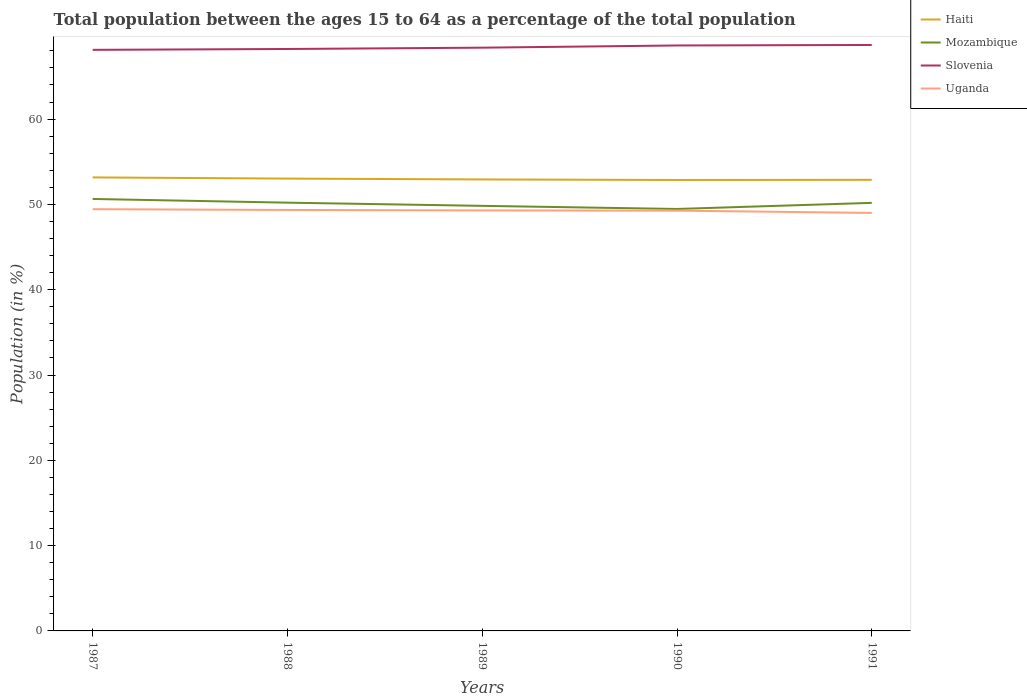Does the line corresponding to Slovenia intersect with the line corresponding to Uganda?
Provide a succinct answer. No. Is the number of lines equal to the number of legend labels?
Provide a succinct answer. Yes. Across all years, what is the maximum percentage of the population ages 15 to 64 in Mozambique?
Your answer should be very brief. 49.46. What is the total percentage of the population ages 15 to 64 in Haiti in the graph?
Your response must be concise. 0.1. What is the difference between the highest and the second highest percentage of the population ages 15 to 64 in Uganda?
Your answer should be very brief. 0.44. Is the percentage of the population ages 15 to 64 in Haiti strictly greater than the percentage of the population ages 15 to 64 in Uganda over the years?
Your answer should be very brief. No. How many lines are there?
Provide a succinct answer. 4. Are the values on the major ticks of Y-axis written in scientific E-notation?
Keep it short and to the point. No. Does the graph contain any zero values?
Keep it short and to the point. No. Does the graph contain grids?
Your answer should be compact. No. How are the legend labels stacked?
Provide a succinct answer. Vertical. What is the title of the graph?
Your response must be concise. Total population between the ages 15 to 64 as a percentage of the total population. What is the label or title of the X-axis?
Your response must be concise. Years. What is the Population (in %) in Haiti in 1987?
Make the answer very short. 53.16. What is the Population (in %) of Mozambique in 1987?
Provide a short and direct response. 50.64. What is the Population (in %) in Slovenia in 1987?
Offer a terse response. 68.12. What is the Population (in %) of Uganda in 1987?
Your answer should be compact. 49.44. What is the Population (in %) in Haiti in 1988?
Offer a terse response. 53.02. What is the Population (in %) of Mozambique in 1988?
Your response must be concise. 50.2. What is the Population (in %) in Slovenia in 1988?
Provide a succinct answer. 68.22. What is the Population (in %) of Uganda in 1988?
Provide a succinct answer. 49.35. What is the Population (in %) in Haiti in 1989?
Keep it short and to the point. 52.93. What is the Population (in %) in Mozambique in 1989?
Keep it short and to the point. 49.83. What is the Population (in %) of Slovenia in 1989?
Provide a succinct answer. 68.37. What is the Population (in %) of Uganda in 1989?
Offer a very short reply. 49.29. What is the Population (in %) of Haiti in 1990?
Your response must be concise. 52.86. What is the Population (in %) in Mozambique in 1990?
Provide a short and direct response. 49.46. What is the Population (in %) in Slovenia in 1990?
Offer a terse response. 68.63. What is the Population (in %) of Uganda in 1990?
Provide a short and direct response. 49.27. What is the Population (in %) in Haiti in 1991?
Keep it short and to the point. 52.88. What is the Population (in %) of Mozambique in 1991?
Offer a very short reply. 50.18. What is the Population (in %) in Slovenia in 1991?
Offer a very short reply. 68.69. What is the Population (in %) of Uganda in 1991?
Keep it short and to the point. 49. Across all years, what is the maximum Population (in %) in Haiti?
Your answer should be very brief. 53.16. Across all years, what is the maximum Population (in %) of Mozambique?
Offer a very short reply. 50.64. Across all years, what is the maximum Population (in %) in Slovenia?
Your answer should be compact. 68.69. Across all years, what is the maximum Population (in %) of Uganda?
Offer a terse response. 49.44. Across all years, what is the minimum Population (in %) in Haiti?
Make the answer very short. 52.86. Across all years, what is the minimum Population (in %) in Mozambique?
Your answer should be compact. 49.46. Across all years, what is the minimum Population (in %) of Slovenia?
Keep it short and to the point. 68.12. Across all years, what is the minimum Population (in %) of Uganda?
Offer a terse response. 49. What is the total Population (in %) of Haiti in the graph?
Your response must be concise. 264.85. What is the total Population (in %) in Mozambique in the graph?
Ensure brevity in your answer.  250.31. What is the total Population (in %) in Slovenia in the graph?
Offer a terse response. 342.02. What is the total Population (in %) in Uganda in the graph?
Make the answer very short. 246.34. What is the difference between the Population (in %) of Haiti in 1987 and that in 1988?
Provide a succinct answer. 0.14. What is the difference between the Population (in %) in Mozambique in 1987 and that in 1988?
Give a very brief answer. 0.43. What is the difference between the Population (in %) of Slovenia in 1987 and that in 1988?
Make the answer very short. -0.1. What is the difference between the Population (in %) in Uganda in 1987 and that in 1988?
Give a very brief answer. 0.09. What is the difference between the Population (in %) in Haiti in 1987 and that in 1989?
Your response must be concise. 0.24. What is the difference between the Population (in %) in Mozambique in 1987 and that in 1989?
Your answer should be compact. 0.81. What is the difference between the Population (in %) of Slovenia in 1987 and that in 1989?
Your response must be concise. -0.26. What is the difference between the Population (in %) in Uganda in 1987 and that in 1989?
Give a very brief answer. 0.15. What is the difference between the Population (in %) in Haiti in 1987 and that in 1990?
Your answer should be compact. 0.3. What is the difference between the Population (in %) of Mozambique in 1987 and that in 1990?
Provide a short and direct response. 1.17. What is the difference between the Population (in %) in Slovenia in 1987 and that in 1990?
Ensure brevity in your answer.  -0.51. What is the difference between the Population (in %) in Uganda in 1987 and that in 1990?
Keep it short and to the point. 0.17. What is the difference between the Population (in %) in Haiti in 1987 and that in 1991?
Your response must be concise. 0.28. What is the difference between the Population (in %) in Mozambique in 1987 and that in 1991?
Your answer should be compact. 0.46. What is the difference between the Population (in %) of Slovenia in 1987 and that in 1991?
Your answer should be compact. -0.57. What is the difference between the Population (in %) of Uganda in 1987 and that in 1991?
Your response must be concise. 0.44. What is the difference between the Population (in %) in Haiti in 1988 and that in 1989?
Keep it short and to the point. 0.1. What is the difference between the Population (in %) in Mozambique in 1988 and that in 1989?
Offer a very short reply. 0.37. What is the difference between the Population (in %) of Slovenia in 1988 and that in 1989?
Offer a very short reply. -0.15. What is the difference between the Population (in %) in Uganda in 1988 and that in 1989?
Provide a short and direct response. 0.06. What is the difference between the Population (in %) of Haiti in 1988 and that in 1990?
Offer a terse response. 0.16. What is the difference between the Population (in %) in Mozambique in 1988 and that in 1990?
Ensure brevity in your answer.  0.74. What is the difference between the Population (in %) of Slovenia in 1988 and that in 1990?
Make the answer very short. -0.41. What is the difference between the Population (in %) in Uganda in 1988 and that in 1990?
Give a very brief answer. 0.08. What is the difference between the Population (in %) of Haiti in 1988 and that in 1991?
Offer a very short reply. 0.14. What is the difference between the Population (in %) of Mozambique in 1988 and that in 1991?
Make the answer very short. 0.02. What is the difference between the Population (in %) of Slovenia in 1988 and that in 1991?
Your answer should be very brief. -0.47. What is the difference between the Population (in %) of Uganda in 1988 and that in 1991?
Give a very brief answer. 0.35. What is the difference between the Population (in %) of Haiti in 1989 and that in 1990?
Provide a short and direct response. 0.07. What is the difference between the Population (in %) in Mozambique in 1989 and that in 1990?
Your response must be concise. 0.37. What is the difference between the Population (in %) in Slovenia in 1989 and that in 1990?
Provide a succinct answer. -0.26. What is the difference between the Population (in %) of Uganda in 1989 and that in 1990?
Your response must be concise. 0.03. What is the difference between the Population (in %) of Haiti in 1989 and that in 1991?
Provide a succinct answer. 0.05. What is the difference between the Population (in %) of Mozambique in 1989 and that in 1991?
Your response must be concise. -0.35. What is the difference between the Population (in %) in Slovenia in 1989 and that in 1991?
Ensure brevity in your answer.  -0.32. What is the difference between the Population (in %) of Uganda in 1989 and that in 1991?
Make the answer very short. 0.29. What is the difference between the Population (in %) of Haiti in 1990 and that in 1991?
Make the answer very short. -0.02. What is the difference between the Population (in %) in Mozambique in 1990 and that in 1991?
Your answer should be very brief. -0.72. What is the difference between the Population (in %) of Slovenia in 1990 and that in 1991?
Provide a succinct answer. -0.06. What is the difference between the Population (in %) of Uganda in 1990 and that in 1991?
Offer a very short reply. 0.26. What is the difference between the Population (in %) of Haiti in 1987 and the Population (in %) of Mozambique in 1988?
Your answer should be very brief. 2.96. What is the difference between the Population (in %) in Haiti in 1987 and the Population (in %) in Slovenia in 1988?
Offer a very short reply. -15.05. What is the difference between the Population (in %) in Haiti in 1987 and the Population (in %) in Uganda in 1988?
Your response must be concise. 3.82. What is the difference between the Population (in %) in Mozambique in 1987 and the Population (in %) in Slovenia in 1988?
Ensure brevity in your answer.  -17.58. What is the difference between the Population (in %) in Mozambique in 1987 and the Population (in %) in Uganda in 1988?
Give a very brief answer. 1.29. What is the difference between the Population (in %) of Slovenia in 1987 and the Population (in %) of Uganda in 1988?
Offer a terse response. 18.77. What is the difference between the Population (in %) of Haiti in 1987 and the Population (in %) of Mozambique in 1989?
Offer a very short reply. 3.33. What is the difference between the Population (in %) of Haiti in 1987 and the Population (in %) of Slovenia in 1989?
Your answer should be very brief. -15.21. What is the difference between the Population (in %) of Haiti in 1987 and the Population (in %) of Uganda in 1989?
Make the answer very short. 3.87. What is the difference between the Population (in %) of Mozambique in 1987 and the Population (in %) of Slovenia in 1989?
Provide a short and direct response. -17.73. What is the difference between the Population (in %) in Mozambique in 1987 and the Population (in %) in Uganda in 1989?
Offer a very short reply. 1.35. What is the difference between the Population (in %) of Slovenia in 1987 and the Population (in %) of Uganda in 1989?
Your answer should be compact. 18.82. What is the difference between the Population (in %) of Haiti in 1987 and the Population (in %) of Mozambique in 1990?
Your response must be concise. 3.7. What is the difference between the Population (in %) in Haiti in 1987 and the Population (in %) in Slovenia in 1990?
Provide a succinct answer. -15.47. What is the difference between the Population (in %) of Haiti in 1987 and the Population (in %) of Uganda in 1990?
Your answer should be compact. 3.9. What is the difference between the Population (in %) in Mozambique in 1987 and the Population (in %) in Slovenia in 1990?
Your answer should be very brief. -17.99. What is the difference between the Population (in %) of Mozambique in 1987 and the Population (in %) of Uganda in 1990?
Make the answer very short. 1.37. What is the difference between the Population (in %) in Slovenia in 1987 and the Population (in %) in Uganda in 1990?
Offer a terse response. 18.85. What is the difference between the Population (in %) of Haiti in 1987 and the Population (in %) of Mozambique in 1991?
Offer a very short reply. 2.98. What is the difference between the Population (in %) of Haiti in 1987 and the Population (in %) of Slovenia in 1991?
Give a very brief answer. -15.52. What is the difference between the Population (in %) in Haiti in 1987 and the Population (in %) in Uganda in 1991?
Your response must be concise. 4.16. What is the difference between the Population (in %) of Mozambique in 1987 and the Population (in %) of Slovenia in 1991?
Provide a succinct answer. -18.05. What is the difference between the Population (in %) of Mozambique in 1987 and the Population (in %) of Uganda in 1991?
Your answer should be compact. 1.64. What is the difference between the Population (in %) of Slovenia in 1987 and the Population (in %) of Uganda in 1991?
Provide a short and direct response. 19.11. What is the difference between the Population (in %) in Haiti in 1988 and the Population (in %) in Mozambique in 1989?
Keep it short and to the point. 3.19. What is the difference between the Population (in %) of Haiti in 1988 and the Population (in %) of Slovenia in 1989?
Ensure brevity in your answer.  -15.35. What is the difference between the Population (in %) of Haiti in 1988 and the Population (in %) of Uganda in 1989?
Your answer should be very brief. 3.73. What is the difference between the Population (in %) of Mozambique in 1988 and the Population (in %) of Slovenia in 1989?
Provide a short and direct response. -18.17. What is the difference between the Population (in %) of Mozambique in 1988 and the Population (in %) of Uganda in 1989?
Your answer should be compact. 0.91. What is the difference between the Population (in %) of Slovenia in 1988 and the Population (in %) of Uganda in 1989?
Make the answer very short. 18.93. What is the difference between the Population (in %) of Haiti in 1988 and the Population (in %) of Mozambique in 1990?
Ensure brevity in your answer.  3.56. What is the difference between the Population (in %) in Haiti in 1988 and the Population (in %) in Slovenia in 1990?
Your answer should be very brief. -15.61. What is the difference between the Population (in %) of Haiti in 1988 and the Population (in %) of Uganda in 1990?
Provide a short and direct response. 3.76. What is the difference between the Population (in %) in Mozambique in 1988 and the Population (in %) in Slovenia in 1990?
Make the answer very short. -18.43. What is the difference between the Population (in %) in Mozambique in 1988 and the Population (in %) in Uganda in 1990?
Ensure brevity in your answer.  0.94. What is the difference between the Population (in %) in Slovenia in 1988 and the Population (in %) in Uganda in 1990?
Provide a short and direct response. 18.95. What is the difference between the Population (in %) of Haiti in 1988 and the Population (in %) of Mozambique in 1991?
Ensure brevity in your answer.  2.84. What is the difference between the Population (in %) in Haiti in 1988 and the Population (in %) in Slovenia in 1991?
Your answer should be compact. -15.66. What is the difference between the Population (in %) in Haiti in 1988 and the Population (in %) in Uganda in 1991?
Give a very brief answer. 4.02. What is the difference between the Population (in %) in Mozambique in 1988 and the Population (in %) in Slovenia in 1991?
Make the answer very short. -18.48. What is the difference between the Population (in %) of Mozambique in 1988 and the Population (in %) of Uganda in 1991?
Your response must be concise. 1.2. What is the difference between the Population (in %) in Slovenia in 1988 and the Population (in %) in Uganda in 1991?
Make the answer very short. 19.22. What is the difference between the Population (in %) in Haiti in 1989 and the Population (in %) in Mozambique in 1990?
Make the answer very short. 3.46. What is the difference between the Population (in %) in Haiti in 1989 and the Population (in %) in Slovenia in 1990?
Your answer should be very brief. -15.7. What is the difference between the Population (in %) in Haiti in 1989 and the Population (in %) in Uganda in 1990?
Offer a very short reply. 3.66. What is the difference between the Population (in %) of Mozambique in 1989 and the Population (in %) of Slovenia in 1990?
Provide a succinct answer. -18.8. What is the difference between the Population (in %) in Mozambique in 1989 and the Population (in %) in Uganda in 1990?
Provide a short and direct response. 0.56. What is the difference between the Population (in %) in Slovenia in 1989 and the Population (in %) in Uganda in 1990?
Offer a very short reply. 19.1. What is the difference between the Population (in %) in Haiti in 1989 and the Population (in %) in Mozambique in 1991?
Ensure brevity in your answer.  2.75. What is the difference between the Population (in %) of Haiti in 1989 and the Population (in %) of Slovenia in 1991?
Provide a short and direct response. -15.76. What is the difference between the Population (in %) of Haiti in 1989 and the Population (in %) of Uganda in 1991?
Your answer should be very brief. 3.92. What is the difference between the Population (in %) of Mozambique in 1989 and the Population (in %) of Slovenia in 1991?
Provide a succinct answer. -18.86. What is the difference between the Population (in %) of Mozambique in 1989 and the Population (in %) of Uganda in 1991?
Provide a short and direct response. 0.83. What is the difference between the Population (in %) in Slovenia in 1989 and the Population (in %) in Uganda in 1991?
Offer a very short reply. 19.37. What is the difference between the Population (in %) of Haiti in 1990 and the Population (in %) of Mozambique in 1991?
Keep it short and to the point. 2.68. What is the difference between the Population (in %) of Haiti in 1990 and the Population (in %) of Slovenia in 1991?
Your answer should be compact. -15.83. What is the difference between the Population (in %) in Haiti in 1990 and the Population (in %) in Uganda in 1991?
Provide a short and direct response. 3.86. What is the difference between the Population (in %) of Mozambique in 1990 and the Population (in %) of Slovenia in 1991?
Offer a very short reply. -19.22. What is the difference between the Population (in %) in Mozambique in 1990 and the Population (in %) in Uganda in 1991?
Your answer should be very brief. 0.46. What is the difference between the Population (in %) of Slovenia in 1990 and the Population (in %) of Uganda in 1991?
Offer a terse response. 19.63. What is the average Population (in %) of Haiti per year?
Provide a succinct answer. 52.97. What is the average Population (in %) in Mozambique per year?
Your response must be concise. 50.06. What is the average Population (in %) of Slovenia per year?
Your answer should be compact. 68.4. What is the average Population (in %) in Uganda per year?
Ensure brevity in your answer.  49.27. In the year 1987, what is the difference between the Population (in %) in Haiti and Population (in %) in Mozambique?
Ensure brevity in your answer.  2.53. In the year 1987, what is the difference between the Population (in %) in Haiti and Population (in %) in Slovenia?
Your response must be concise. -14.95. In the year 1987, what is the difference between the Population (in %) of Haiti and Population (in %) of Uganda?
Provide a short and direct response. 3.73. In the year 1987, what is the difference between the Population (in %) in Mozambique and Population (in %) in Slovenia?
Your answer should be very brief. -17.48. In the year 1987, what is the difference between the Population (in %) in Mozambique and Population (in %) in Uganda?
Provide a short and direct response. 1.2. In the year 1987, what is the difference between the Population (in %) in Slovenia and Population (in %) in Uganda?
Your response must be concise. 18.68. In the year 1988, what is the difference between the Population (in %) of Haiti and Population (in %) of Mozambique?
Your response must be concise. 2.82. In the year 1988, what is the difference between the Population (in %) of Haiti and Population (in %) of Slovenia?
Your answer should be very brief. -15.19. In the year 1988, what is the difference between the Population (in %) in Haiti and Population (in %) in Uganda?
Your response must be concise. 3.68. In the year 1988, what is the difference between the Population (in %) in Mozambique and Population (in %) in Slovenia?
Give a very brief answer. -18.01. In the year 1988, what is the difference between the Population (in %) of Mozambique and Population (in %) of Uganda?
Your answer should be compact. 0.85. In the year 1988, what is the difference between the Population (in %) in Slovenia and Population (in %) in Uganda?
Provide a succinct answer. 18.87. In the year 1989, what is the difference between the Population (in %) of Haiti and Population (in %) of Mozambique?
Provide a short and direct response. 3.1. In the year 1989, what is the difference between the Population (in %) in Haiti and Population (in %) in Slovenia?
Offer a very short reply. -15.45. In the year 1989, what is the difference between the Population (in %) in Haiti and Population (in %) in Uganda?
Your answer should be compact. 3.63. In the year 1989, what is the difference between the Population (in %) of Mozambique and Population (in %) of Slovenia?
Ensure brevity in your answer.  -18.54. In the year 1989, what is the difference between the Population (in %) of Mozambique and Population (in %) of Uganda?
Your answer should be very brief. 0.54. In the year 1989, what is the difference between the Population (in %) in Slovenia and Population (in %) in Uganda?
Give a very brief answer. 19.08. In the year 1990, what is the difference between the Population (in %) in Haiti and Population (in %) in Mozambique?
Provide a short and direct response. 3.4. In the year 1990, what is the difference between the Population (in %) of Haiti and Population (in %) of Slovenia?
Your answer should be compact. -15.77. In the year 1990, what is the difference between the Population (in %) in Haiti and Population (in %) in Uganda?
Keep it short and to the point. 3.59. In the year 1990, what is the difference between the Population (in %) in Mozambique and Population (in %) in Slovenia?
Your response must be concise. -19.17. In the year 1990, what is the difference between the Population (in %) in Mozambique and Population (in %) in Uganda?
Your answer should be very brief. 0.2. In the year 1990, what is the difference between the Population (in %) of Slovenia and Population (in %) of Uganda?
Your answer should be compact. 19.36. In the year 1991, what is the difference between the Population (in %) of Haiti and Population (in %) of Mozambique?
Your answer should be very brief. 2.7. In the year 1991, what is the difference between the Population (in %) of Haiti and Population (in %) of Slovenia?
Give a very brief answer. -15.81. In the year 1991, what is the difference between the Population (in %) in Haiti and Population (in %) in Uganda?
Offer a very short reply. 3.88. In the year 1991, what is the difference between the Population (in %) of Mozambique and Population (in %) of Slovenia?
Your answer should be very brief. -18.51. In the year 1991, what is the difference between the Population (in %) in Mozambique and Population (in %) in Uganda?
Keep it short and to the point. 1.18. In the year 1991, what is the difference between the Population (in %) in Slovenia and Population (in %) in Uganda?
Your response must be concise. 19.69. What is the ratio of the Population (in %) of Mozambique in 1987 to that in 1988?
Keep it short and to the point. 1.01. What is the ratio of the Population (in %) in Mozambique in 1987 to that in 1989?
Provide a succinct answer. 1.02. What is the ratio of the Population (in %) in Mozambique in 1987 to that in 1990?
Offer a very short reply. 1.02. What is the ratio of the Population (in %) of Uganda in 1987 to that in 1990?
Offer a terse response. 1. What is the ratio of the Population (in %) in Haiti in 1987 to that in 1991?
Your answer should be very brief. 1.01. What is the ratio of the Population (in %) of Mozambique in 1987 to that in 1991?
Your response must be concise. 1.01. What is the ratio of the Population (in %) in Uganda in 1987 to that in 1991?
Your response must be concise. 1.01. What is the ratio of the Population (in %) of Mozambique in 1988 to that in 1989?
Your answer should be very brief. 1.01. What is the ratio of the Population (in %) of Slovenia in 1988 to that in 1990?
Give a very brief answer. 0.99. What is the ratio of the Population (in %) in Haiti in 1988 to that in 1991?
Keep it short and to the point. 1. What is the ratio of the Population (in %) of Slovenia in 1988 to that in 1991?
Your answer should be compact. 0.99. What is the ratio of the Population (in %) of Uganda in 1988 to that in 1991?
Your answer should be very brief. 1.01. What is the ratio of the Population (in %) of Mozambique in 1989 to that in 1990?
Provide a short and direct response. 1.01. What is the ratio of the Population (in %) of Mozambique in 1989 to that in 1991?
Your answer should be very brief. 0.99. What is the ratio of the Population (in %) in Slovenia in 1989 to that in 1991?
Your answer should be compact. 1. What is the ratio of the Population (in %) of Uganda in 1989 to that in 1991?
Ensure brevity in your answer.  1.01. What is the ratio of the Population (in %) of Mozambique in 1990 to that in 1991?
Give a very brief answer. 0.99. What is the ratio of the Population (in %) of Slovenia in 1990 to that in 1991?
Keep it short and to the point. 1. What is the ratio of the Population (in %) in Uganda in 1990 to that in 1991?
Your answer should be compact. 1.01. What is the difference between the highest and the second highest Population (in %) of Haiti?
Keep it short and to the point. 0.14. What is the difference between the highest and the second highest Population (in %) in Mozambique?
Your answer should be compact. 0.43. What is the difference between the highest and the second highest Population (in %) of Slovenia?
Your response must be concise. 0.06. What is the difference between the highest and the second highest Population (in %) in Uganda?
Provide a short and direct response. 0.09. What is the difference between the highest and the lowest Population (in %) in Haiti?
Your answer should be compact. 0.3. What is the difference between the highest and the lowest Population (in %) in Mozambique?
Keep it short and to the point. 1.17. What is the difference between the highest and the lowest Population (in %) of Slovenia?
Provide a succinct answer. 0.57. What is the difference between the highest and the lowest Population (in %) in Uganda?
Your response must be concise. 0.44. 